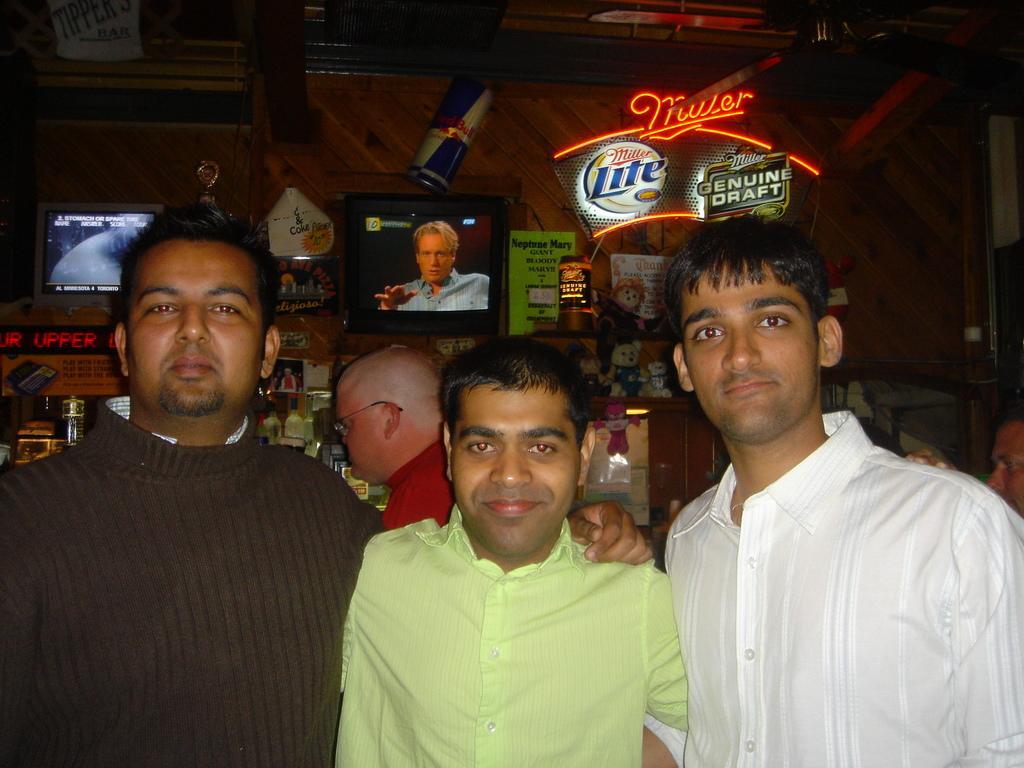Please provide a concise description of this image. In this picture we can see three people, they are smiling and in the background we can see people, televisions, wall and some objects. 